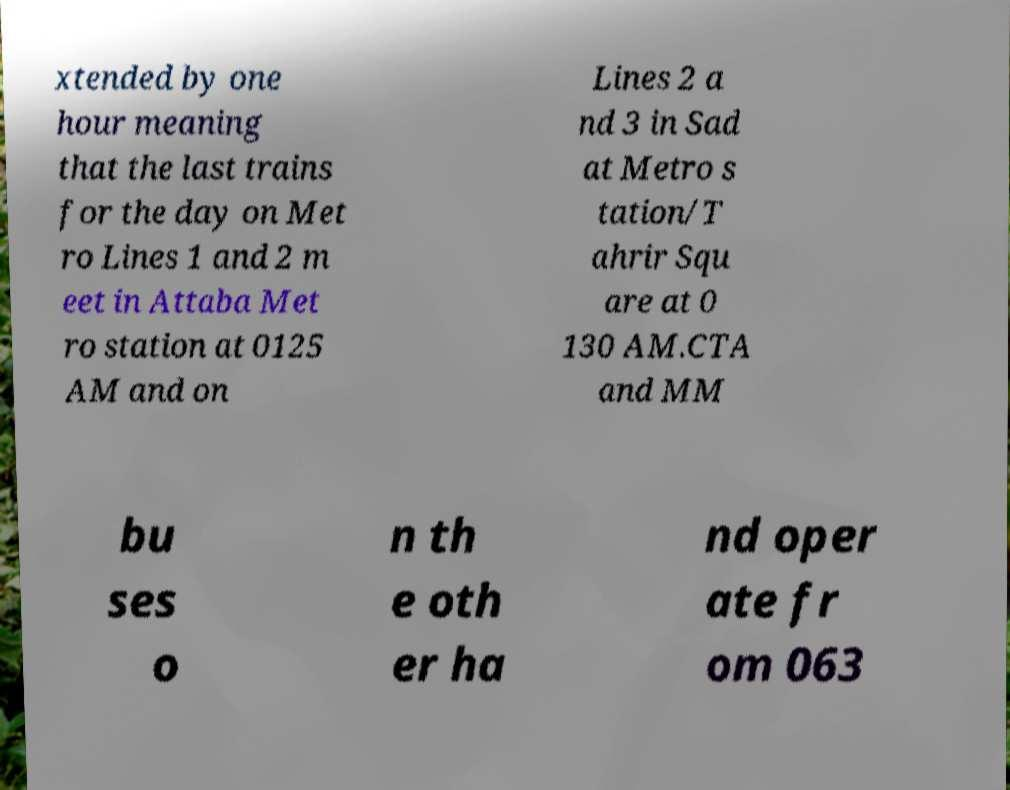What messages or text are displayed in this image? I need them in a readable, typed format. xtended by one hour meaning that the last trains for the day on Met ro Lines 1 and 2 m eet in Attaba Met ro station at 0125 AM and on Lines 2 a nd 3 in Sad at Metro s tation/T ahrir Squ are at 0 130 AM.CTA and MM bu ses o n th e oth er ha nd oper ate fr om 063 